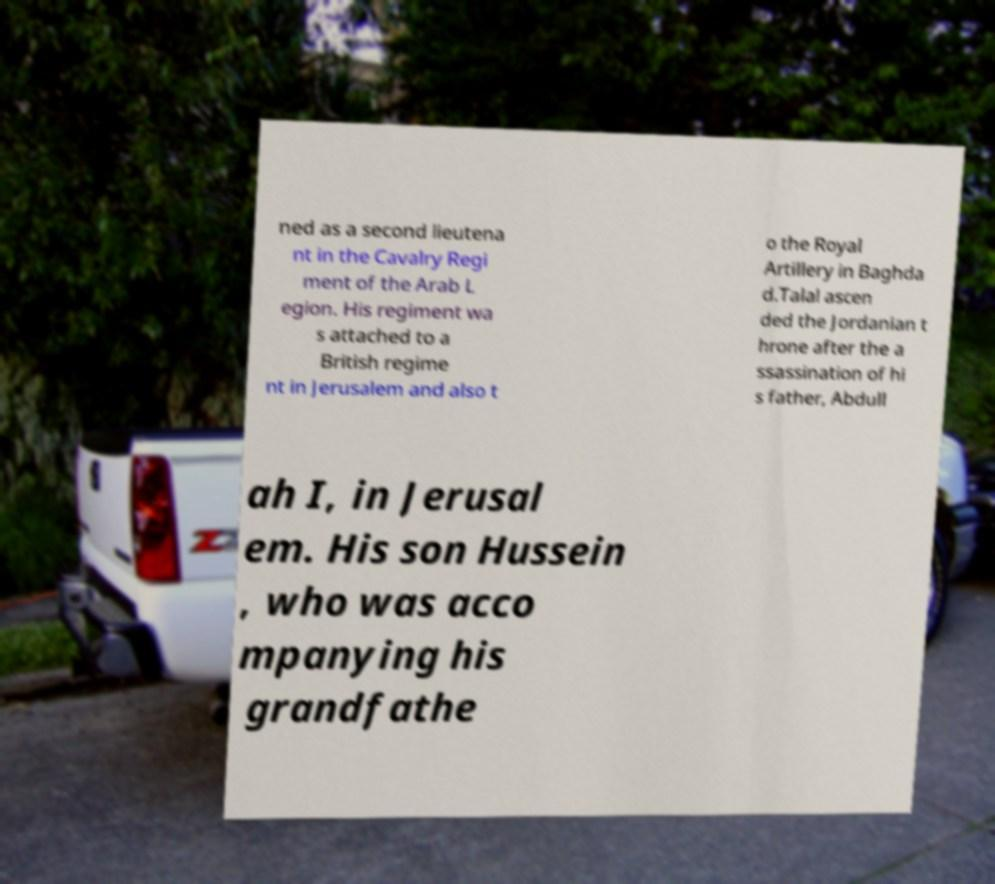What messages or text are displayed in this image? I need them in a readable, typed format. ned as a second lieutena nt in the Cavalry Regi ment of the Arab L egion. His regiment wa s attached to a British regime nt in Jerusalem and also t o the Royal Artillery in Baghda d.Talal ascen ded the Jordanian t hrone after the a ssassination of hi s father, Abdull ah I, in Jerusal em. His son Hussein , who was acco mpanying his grandfathe 